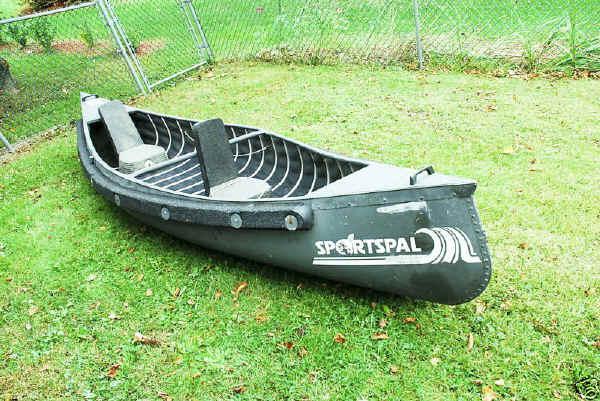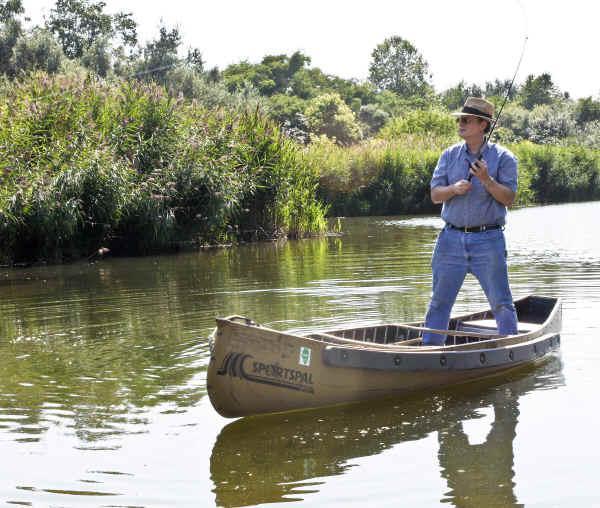The first image is the image on the left, the second image is the image on the right. Evaluate the accuracy of this statement regarding the images: "the image on the righ contains humans". Is it true? Answer yes or no. Yes. 